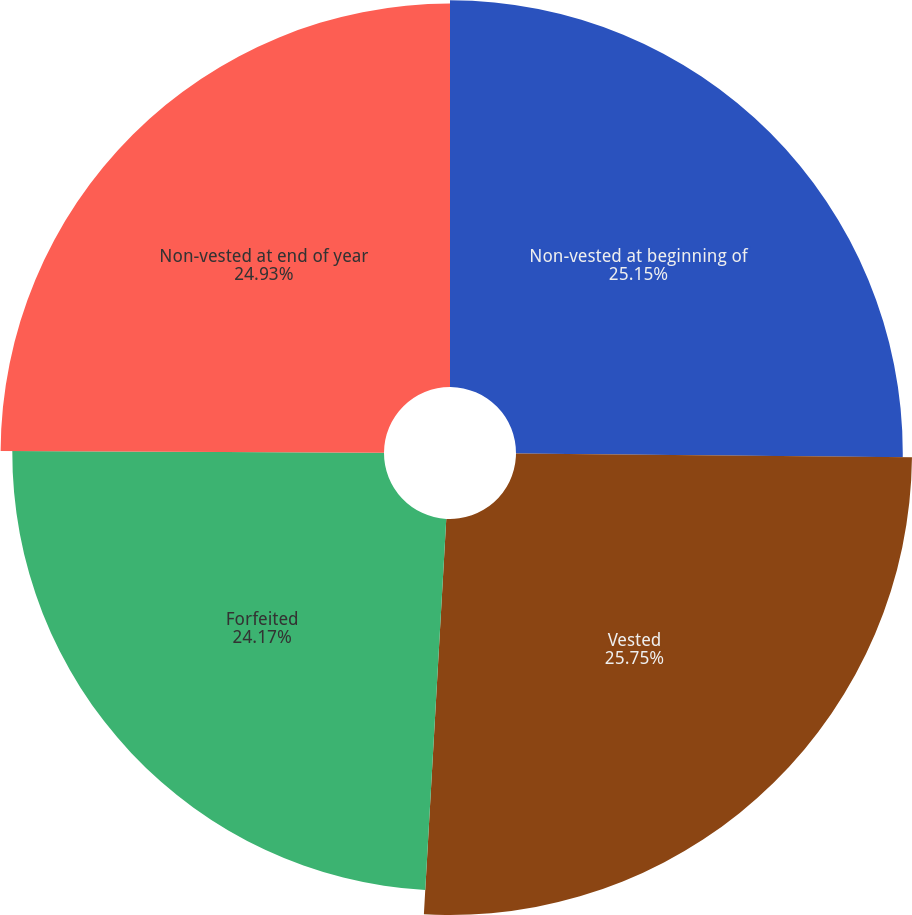<chart> <loc_0><loc_0><loc_500><loc_500><pie_chart><fcel>Non-vested at beginning of<fcel>Vested<fcel>Forfeited<fcel>Non-vested at end of year<nl><fcel>25.15%<fcel>25.75%<fcel>24.17%<fcel>24.93%<nl></chart> 